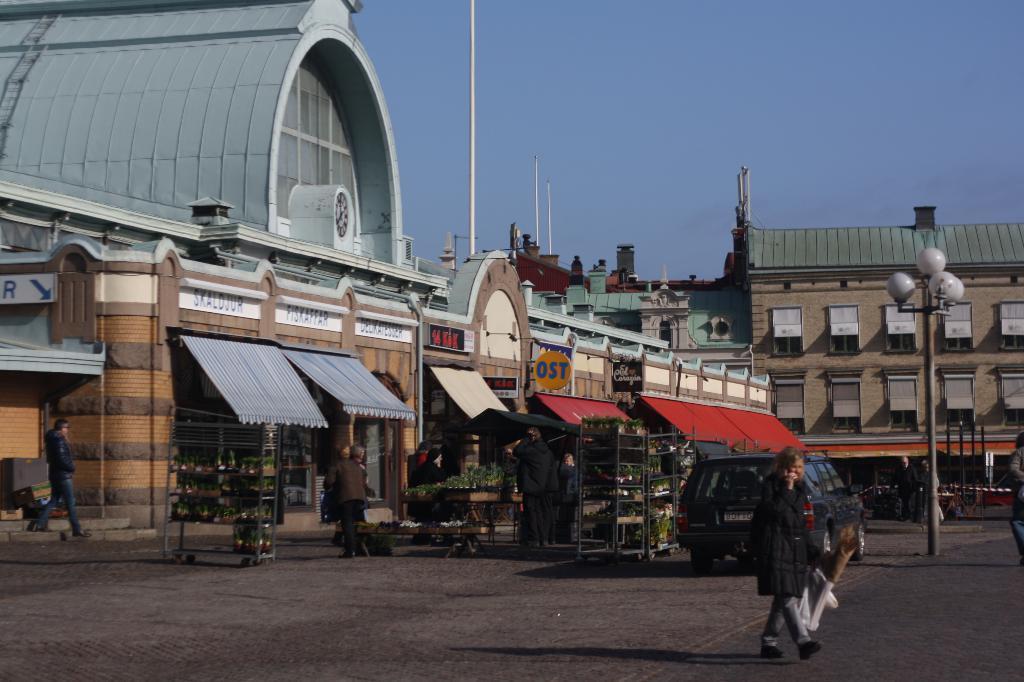In one or two sentences, can you explain what this image depicts? There is a person walking and holding an object. We can see car on the surface. There are people and we can see lights on pole. We can see buildings, poles, stores and sky. 